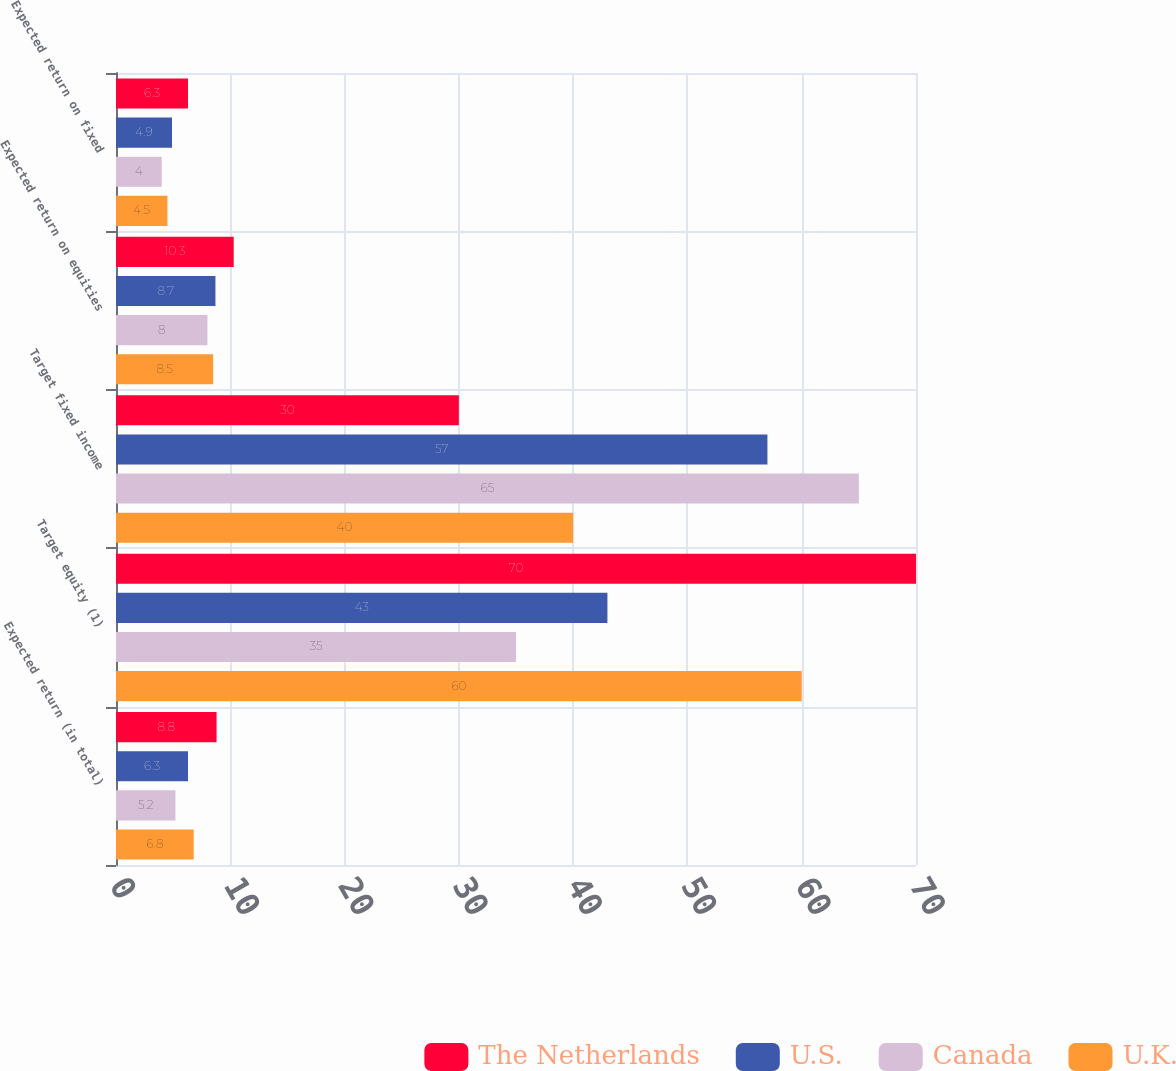Convert chart. <chart><loc_0><loc_0><loc_500><loc_500><stacked_bar_chart><ecel><fcel>Expected return (in total)<fcel>Target equity (1)<fcel>Target fixed income<fcel>Expected return on equities<fcel>Expected return on fixed<nl><fcel>The Netherlands<fcel>8.8<fcel>70<fcel>30<fcel>10.3<fcel>6.3<nl><fcel>U.S.<fcel>6.3<fcel>43<fcel>57<fcel>8.7<fcel>4.9<nl><fcel>Canada<fcel>5.2<fcel>35<fcel>65<fcel>8<fcel>4<nl><fcel>U.K.<fcel>6.8<fcel>60<fcel>40<fcel>8.5<fcel>4.5<nl></chart> 